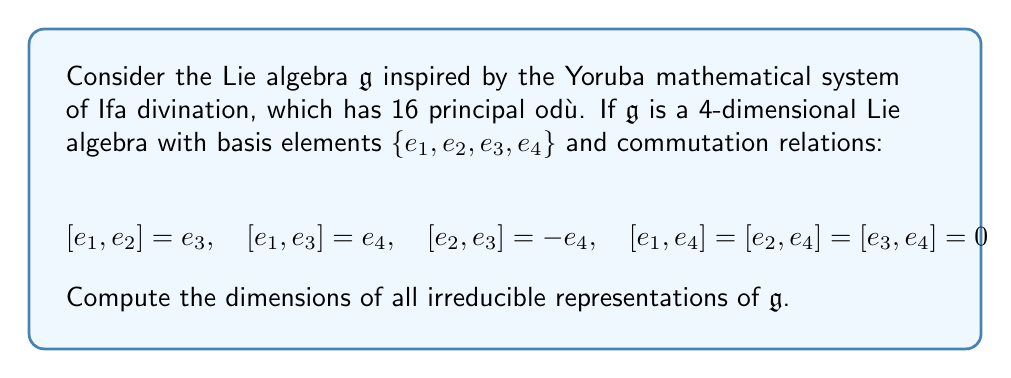Show me your answer to this math problem. To find the dimensions of irreducible representations, we'll follow these steps:

1) First, we need to identify the center of the Lie algebra. The center $Z(\mathfrak{g})$ consists of elements that commute with all other elements.

   From the given commutation relations, we can see that $e_4$ commutes with all other basis elements. Therefore, $Z(\mathfrak{g}) = \text{span}\{e_4\}$.

2) Next, we note that $\mathfrak{g}/Z(\mathfrak{g})$ is a 3-dimensional Lie algebra. Its structure is similar to the Heisenberg algebra.

3) For a Lie algebra over an algebraically closed field of characteristic zero (like $\mathbb{C}$), Schur's lemma implies that elements of the center act as scalar multiples of the identity in any irreducible representation.

4) The quotient algebra $\mathfrak{g}/Z(\mathfrak{g})$ is nilpotent. For nilpotent Lie algebras, all irreducible representations are 1-dimensional (this is a consequence of Lie's theorem).

5) Therefore, any irreducible representation of $\mathfrak{g}$ must be 1-dimensional when restricted to $\mathfrak{g}/Z(\mathfrak{g})$.

6) Since $Z(\mathfrak{g})$ acts by scalar multiplication, it doesn't increase the dimension of the representation.

Thus, all irreducible representations of $\mathfrak{g}$ are 1-dimensional.
Answer: 1 